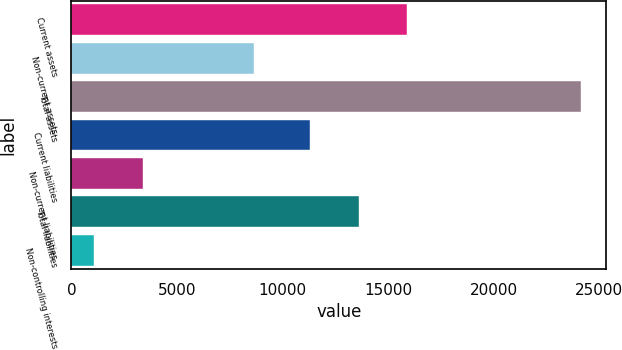Convert chart to OTSL. <chart><loc_0><loc_0><loc_500><loc_500><bar_chart><fcel>Current assets<fcel>Non-current assets<fcel>Total assets<fcel>Current liabilities<fcel>Non-current liabilities<fcel>Total liabilities<fcel>Non-controlling interests<nl><fcel>15913.2<fcel>8668<fcel>24129<fcel>11303<fcel>3383.1<fcel>13608.1<fcel>1078<nl></chart> 